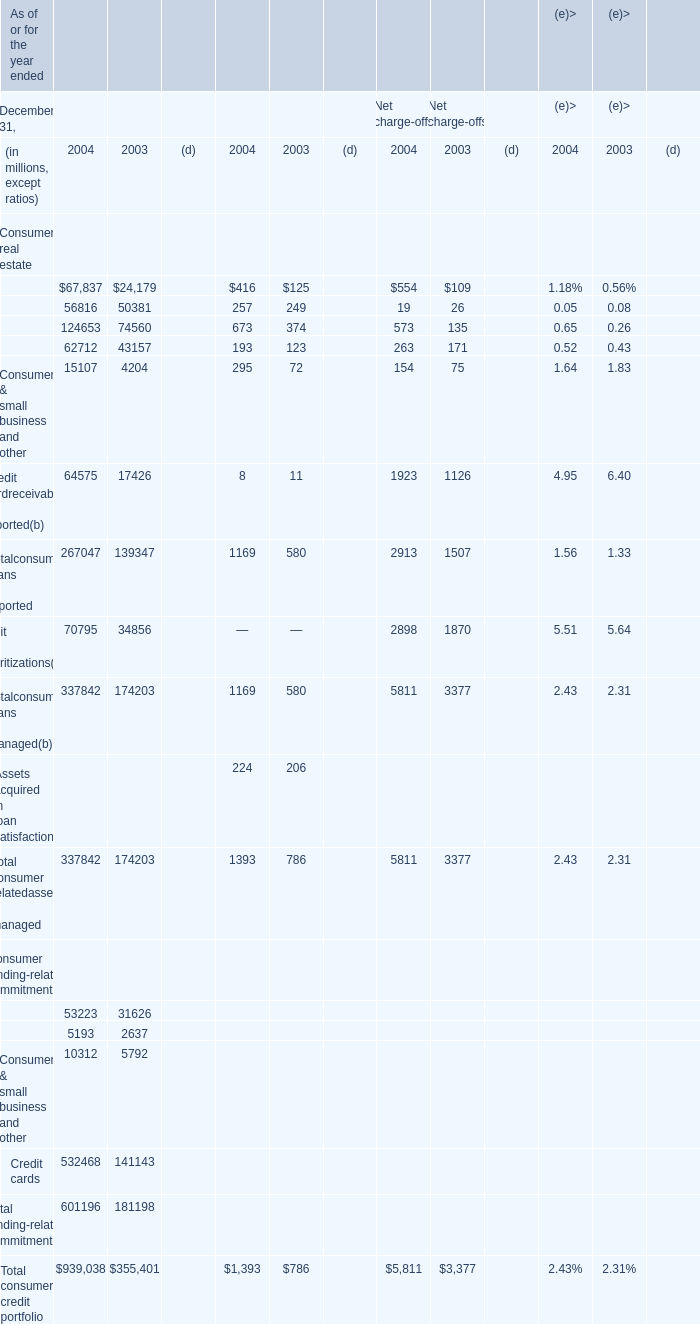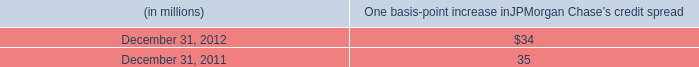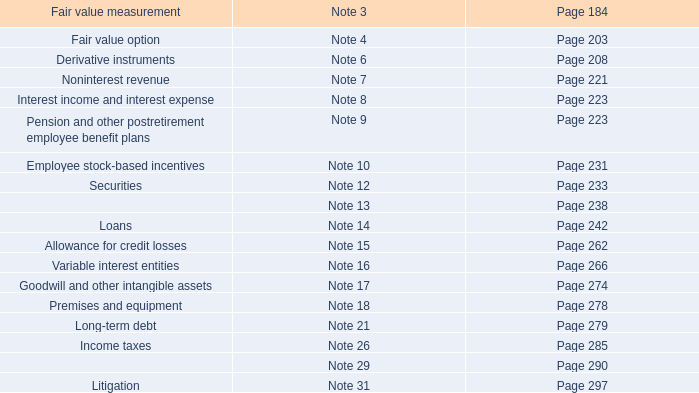In which years is Home finance– home equity and other(a) greater than Home finance– mortgage? 
Answer: 2003 2004. 